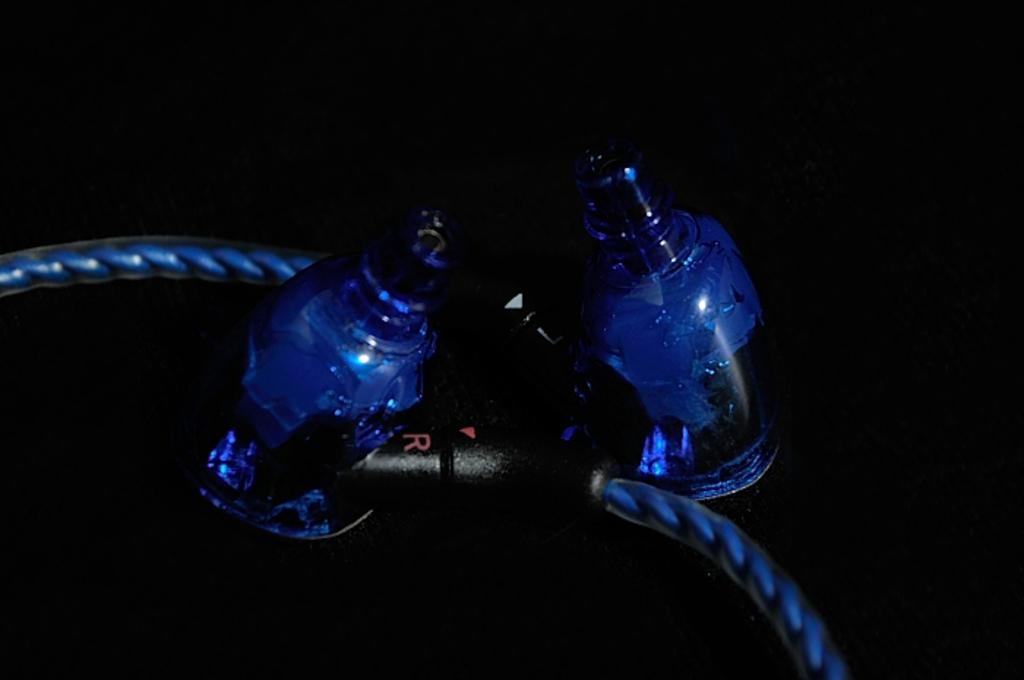Provide a one-sentence caption for the provided image. Cables connect two plastic items and have a black piece with a R and L on either side. 